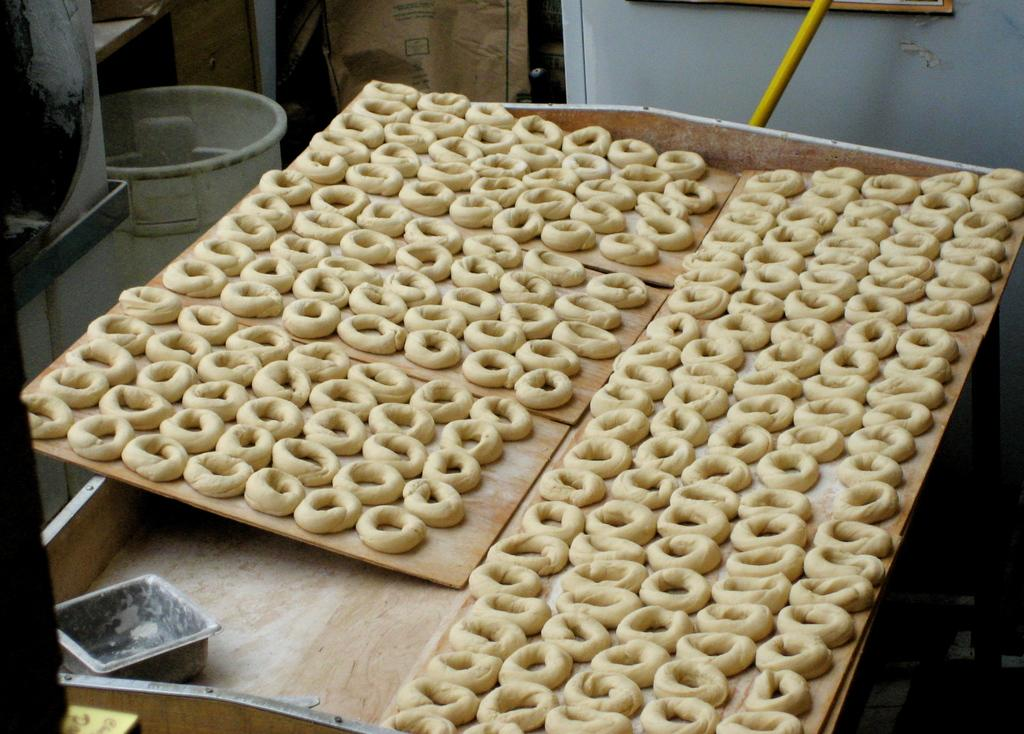What type of food items can be seen in the image? The image contains food items, but the specific types are not mentioned in the facts. On what surface are the food items placed? The food items are on a wooden surface. What is the container used for in the image? The container's purpose is not specified in the facts. Can you describe any other objects present in the image? There are other objects in the image, but their nature is not mentioned in the facts. How does the mine increase its production in the image? There is no mine present in the image; it contains food items, a wooden surface, a container, and other objects. 